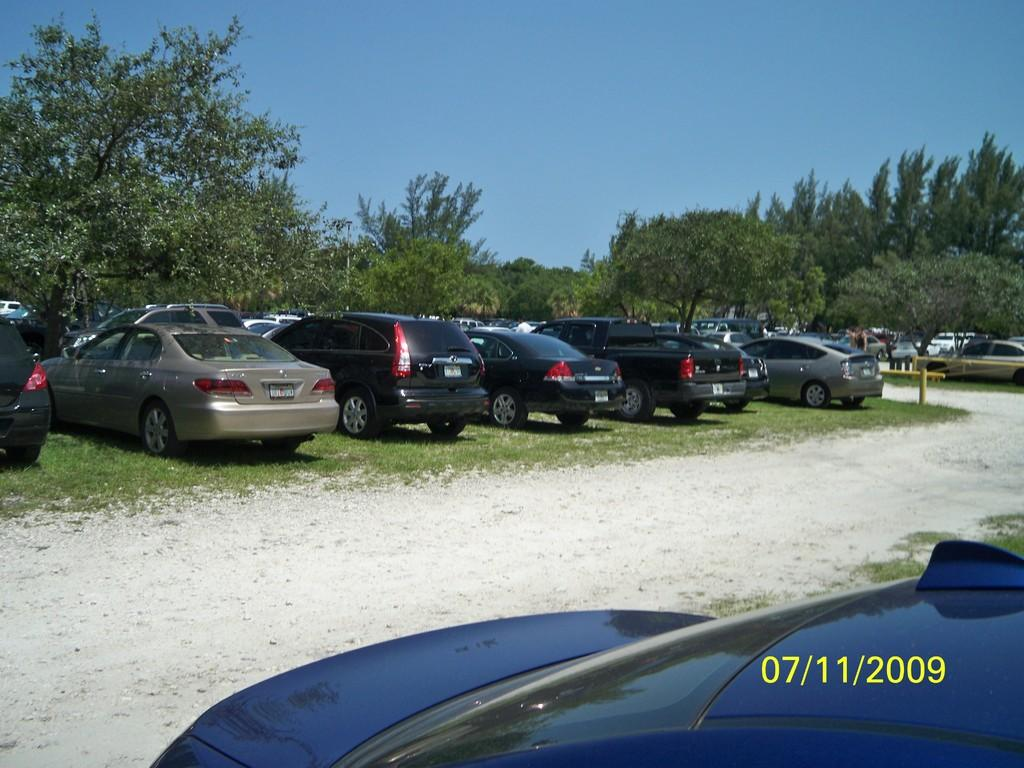What types of objects are on the ground in the image? There are vehicles on the ground in the image. What can be seen in the background of the image? There are many trees and the sky visible in the background of the image. How many rings are hanging from the trees in the image? There are no rings visible in the image; only trees and the sky are present in the background. 